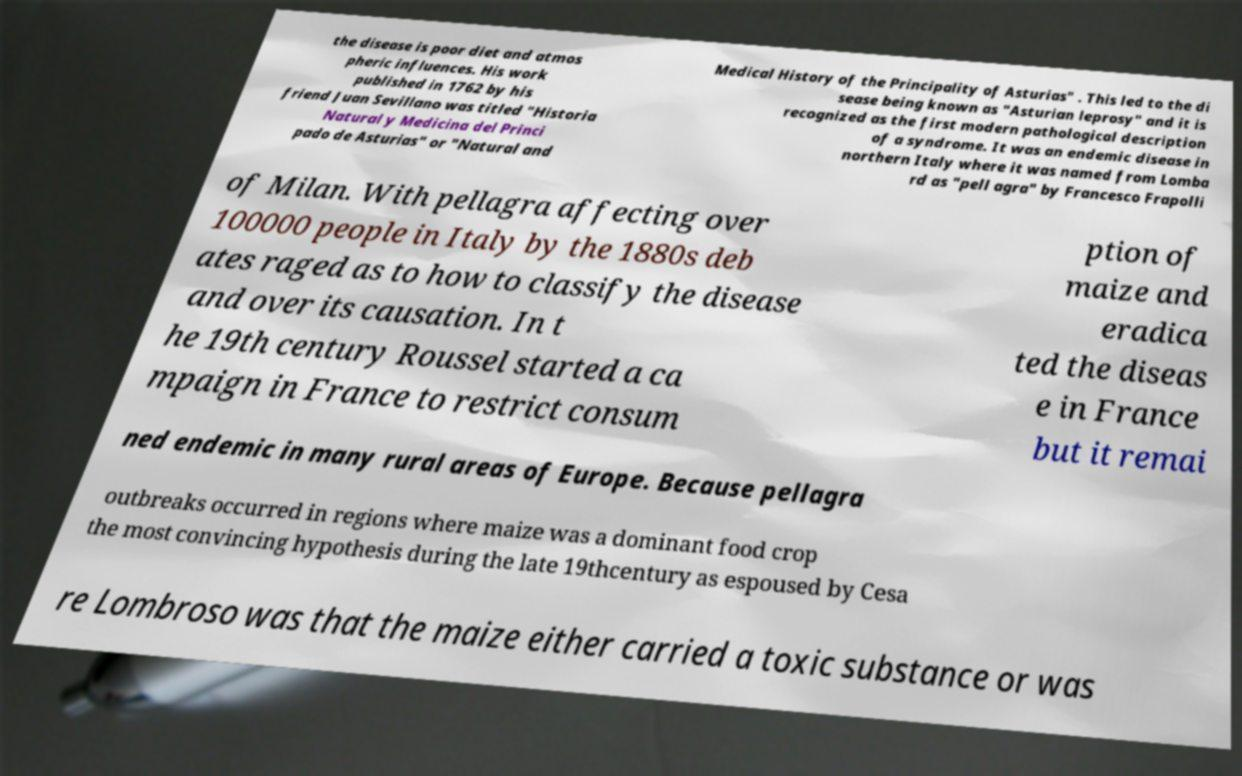Could you assist in decoding the text presented in this image and type it out clearly? the disease is poor diet and atmos pheric influences. His work published in 1762 by his friend Juan Sevillano was titled "Historia Natural y Medicina del Princi pado de Asturias" or "Natural and Medical History of the Principality of Asturias" . This led to the di sease being known as "Asturian leprosy" and it is recognized as the first modern pathological description of a syndrome. It was an endemic disease in northern Italy where it was named from Lomba rd as "pell agra" by Francesco Frapolli of Milan. With pellagra affecting over 100000 people in Italy by the 1880s deb ates raged as to how to classify the disease and over its causation. In t he 19th century Roussel started a ca mpaign in France to restrict consum ption of maize and eradica ted the diseas e in France but it remai ned endemic in many rural areas of Europe. Because pellagra outbreaks occurred in regions where maize was a dominant food crop the most convincing hypothesis during the late 19thcentury as espoused by Cesa re Lombroso was that the maize either carried a toxic substance or was 